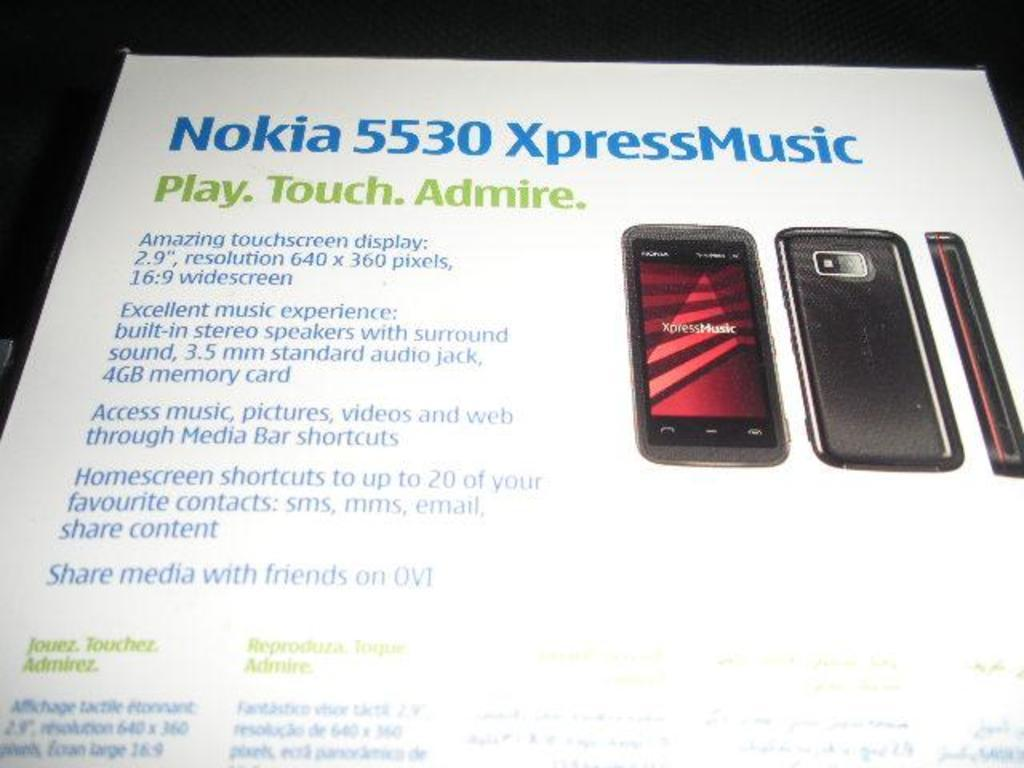<image>
Present a compact description of the photo's key features. an ad for nokia 5530 xpressmusic written in blue across the top 